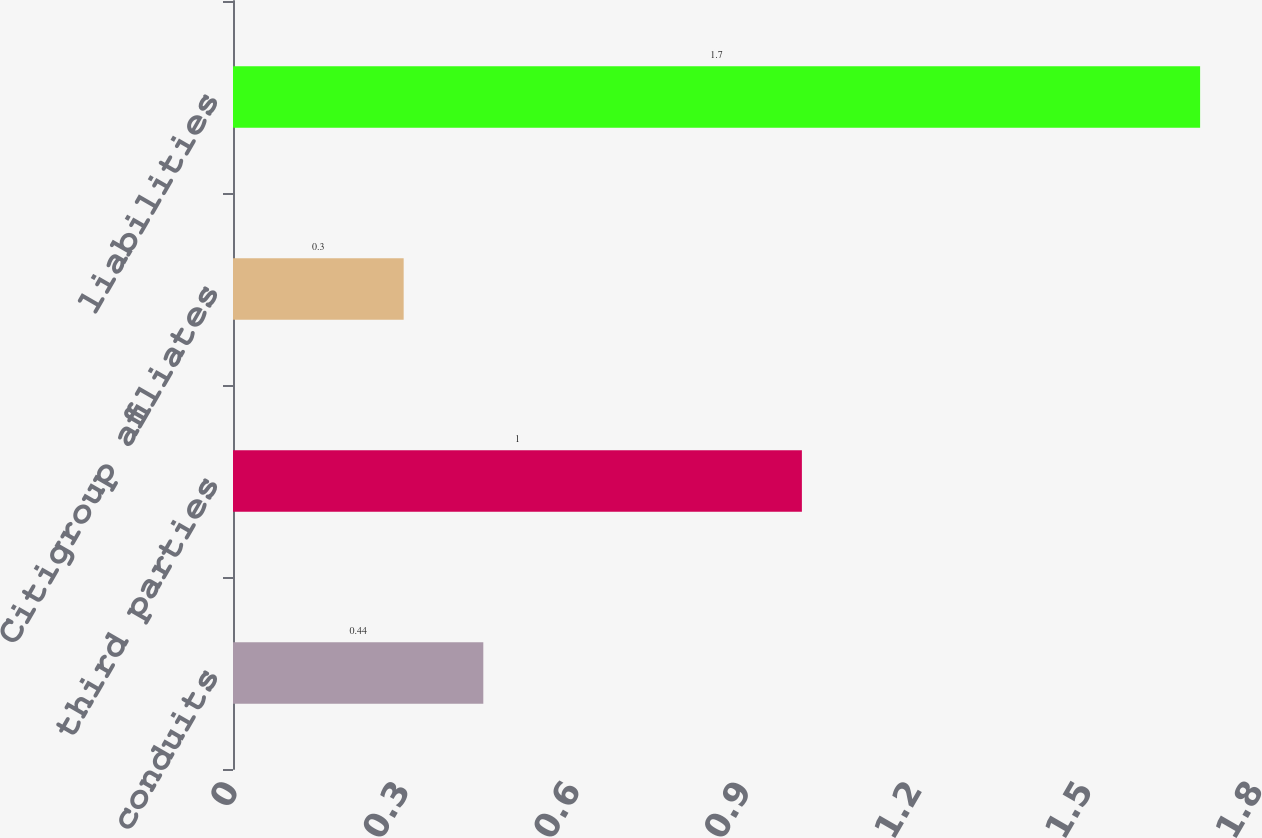Convert chart to OTSL. <chart><loc_0><loc_0><loc_500><loc_500><bar_chart><fcel>conduits<fcel>third parties<fcel>Citigroup affiliates<fcel>liabilities<nl><fcel>0.44<fcel>1<fcel>0.3<fcel>1.7<nl></chart> 